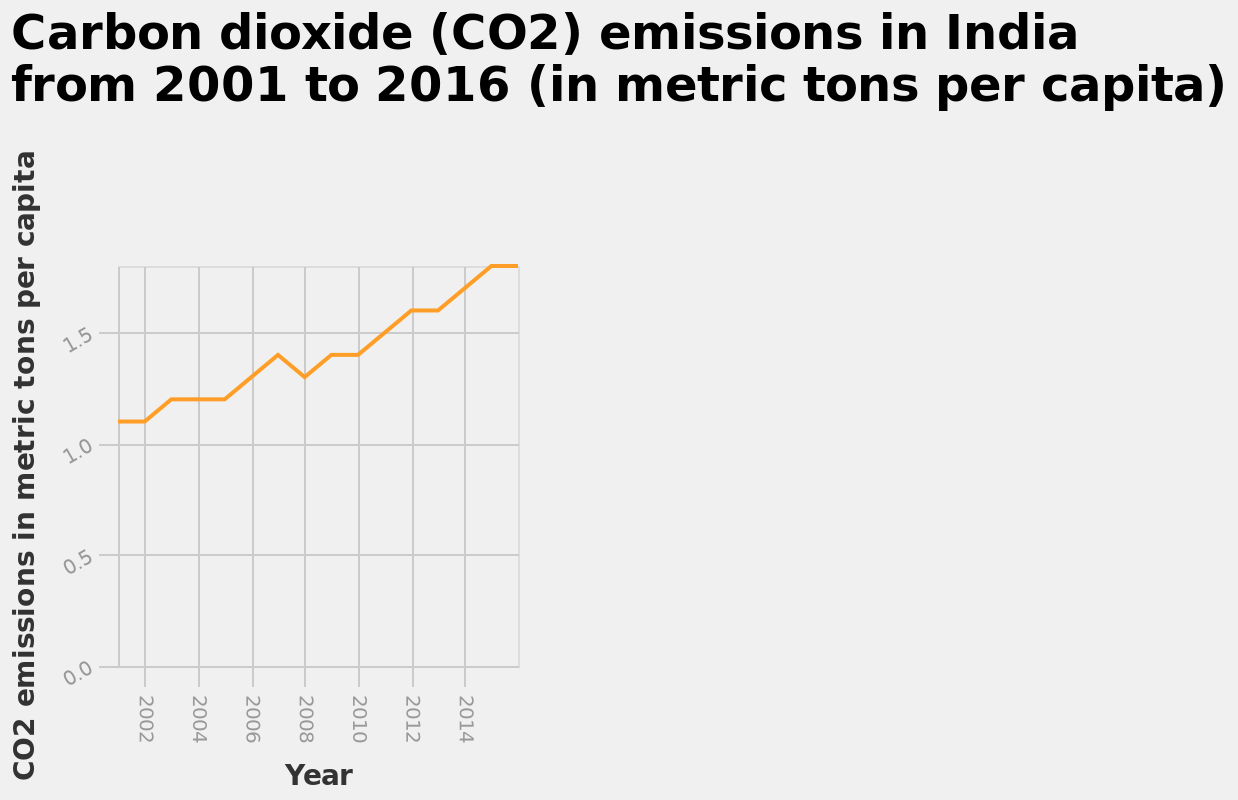<image>
What is the maximum value on the y-axis of the line chart? The maximum value on the y-axis of the line chart is 1.5 metric tons per capita. Did CO2 emissions pick up again after a certain year? Yes, CO2 emissions picked up again after 2010. please describe the details of the chart This is a line chart called Carbon dioxide (CO2) emissions in India from 2001 to 2016 (in metric tons per capita). There is a linear scale of range 2002 to 2014 along the x-axis, marked Year. On the y-axis, CO2 emissions in metric tons per capita is shown with a linear scale with a minimum of 0.0 and a maximum of 1.5. 